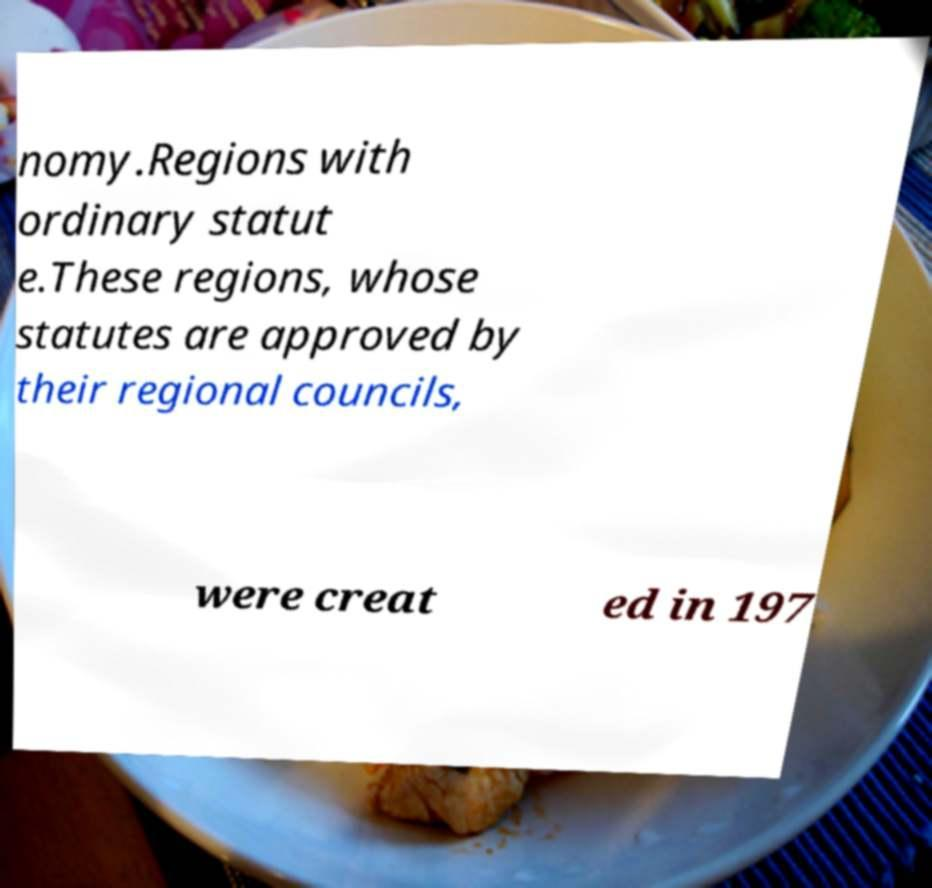Can you accurately transcribe the text from the provided image for me? nomy.Regions with ordinary statut e.These regions, whose statutes are approved by their regional councils, were creat ed in 197 